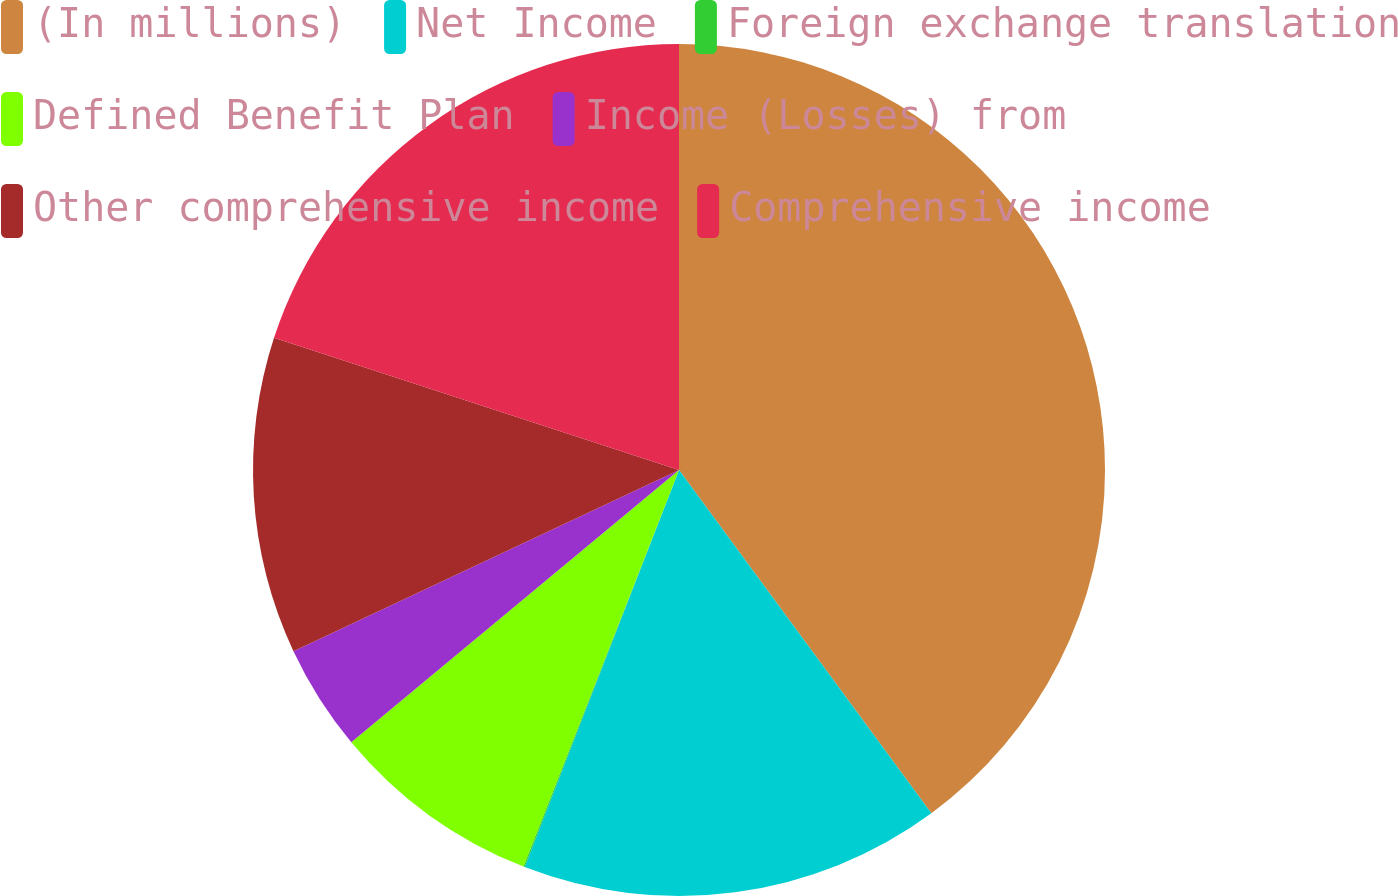Convert chart to OTSL. <chart><loc_0><loc_0><loc_500><loc_500><pie_chart><fcel>(In millions)<fcel>Net Income<fcel>Foreign exchange translation<fcel>Defined Benefit Plan<fcel>Income (Losses) from<fcel>Other comprehensive income<fcel>Comprehensive income<nl><fcel>39.91%<fcel>15.99%<fcel>0.05%<fcel>8.02%<fcel>4.04%<fcel>12.01%<fcel>19.98%<nl></chart> 